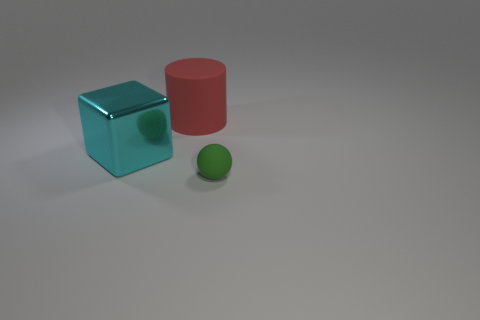Subtract 1 spheres. How many spheres are left? 0 Add 3 large gray things. How many objects exist? 6 Subtract all brown balls. How many gray cylinders are left? 0 Add 3 big red cylinders. How many big red cylinders are left? 4 Add 3 tiny green rubber things. How many tiny green rubber things exist? 4 Subtract 0 gray blocks. How many objects are left? 3 Subtract all spheres. How many objects are left? 2 Subtract all blocks. Subtract all large red rubber cubes. How many objects are left? 2 